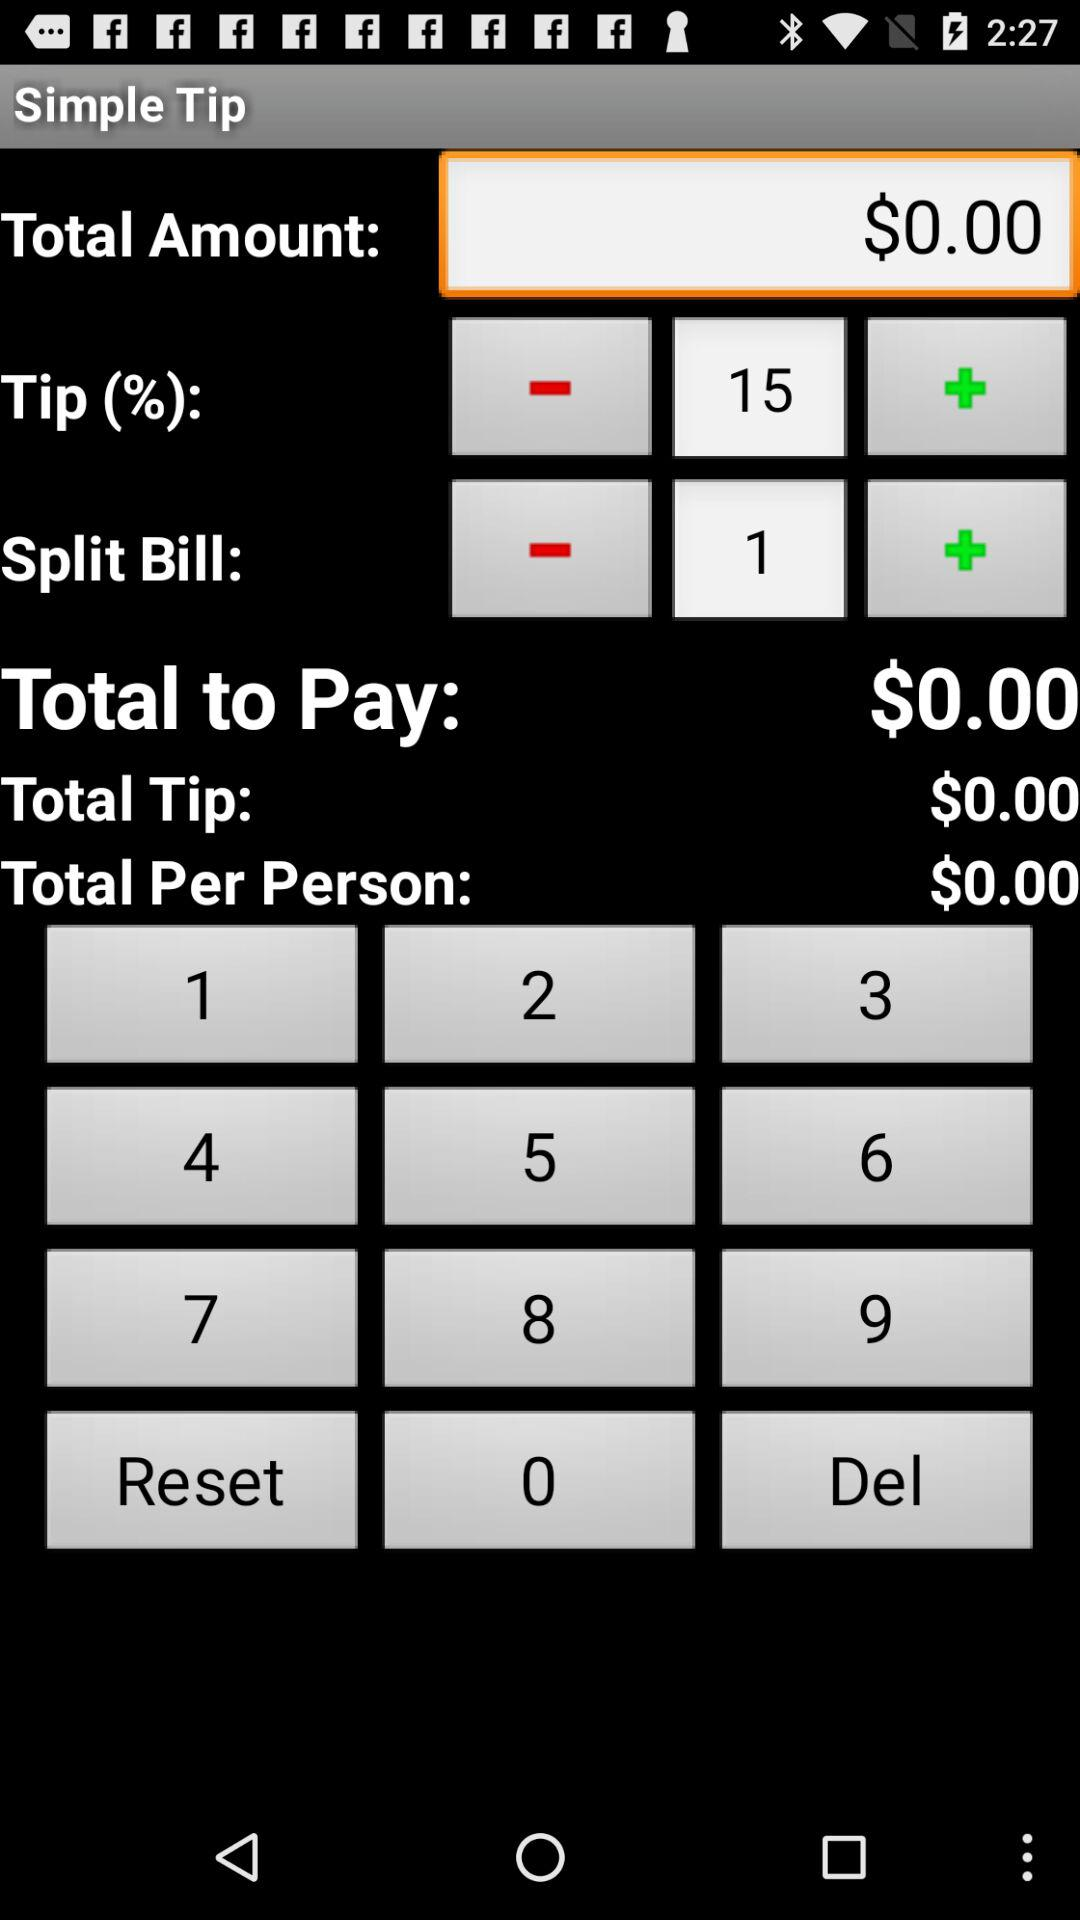How much is the total tip?
Answer the question using a single word or phrase. $0.00 